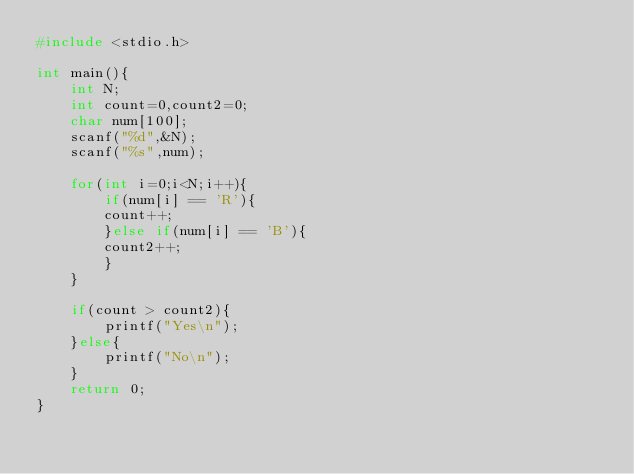Convert code to text. <code><loc_0><loc_0><loc_500><loc_500><_C_>#include <stdio.h>

int main(){
	int N;
	int count=0,count2=0;
	char num[100];
	scanf("%d",&N);
	scanf("%s",num);

	for(int i=0;i<N;i++){
		if(num[i] == 'R'){
		count++;
		}else if(num[i] == 'B'){
		count2++;
		}
	}

	if(count > count2){
		printf("Yes\n");
	}else{
		printf("No\n");
	}
	return 0;
}</code> 